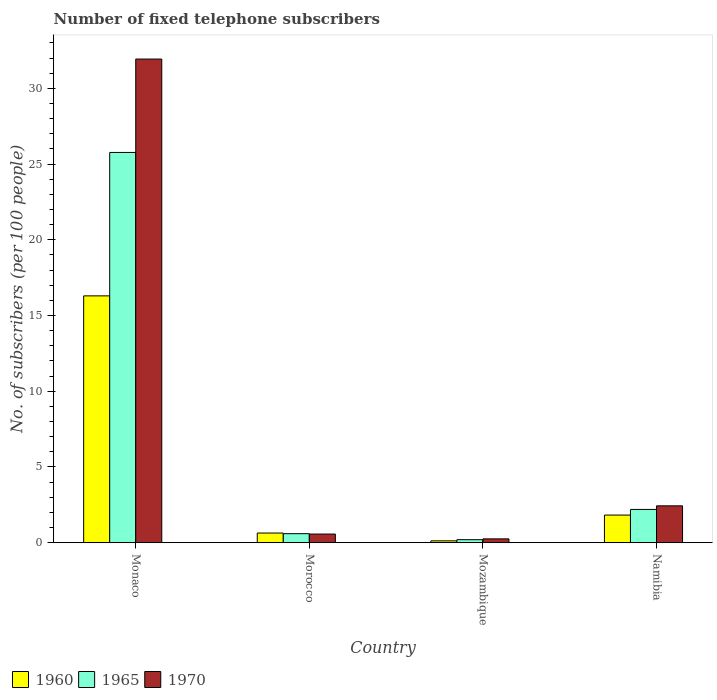Are the number of bars per tick equal to the number of legend labels?
Provide a short and direct response. Yes. Are the number of bars on each tick of the X-axis equal?
Make the answer very short. Yes. What is the label of the 4th group of bars from the left?
Provide a short and direct response. Namibia. What is the number of fixed telephone subscribers in 1965 in Mozambique?
Your answer should be compact. 0.2. Across all countries, what is the maximum number of fixed telephone subscribers in 1965?
Keep it short and to the point. 25.77. Across all countries, what is the minimum number of fixed telephone subscribers in 1970?
Your response must be concise. 0.25. In which country was the number of fixed telephone subscribers in 1970 maximum?
Your response must be concise. Monaco. In which country was the number of fixed telephone subscribers in 1960 minimum?
Your answer should be very brief. Mozambique. What is the total number of fixed telephone subscribers in 1970 in the graph?
Provide a short and direct response. 35.2. What is the difference between the number of fixed telephone subscribers in 1970 in Monaco and that in Namibia?
Keep it short and to the point. 29.5. What is the difference between the number of fixed telephone subscribers in 1965 in Morocco and the number of fixed telephone subscribers in 1960 in Namibia?
Make the answer very short. -1.23. What is the average number of fixed telephone subscribers in 1960 per country?
Your answer should be very brief. 4.72. What is the difference between the number of fixed telephone subscribers of/in 1970 and number of fixed telephone subscribers of/in 1960 in Mozambique?
Ensure brevity in your answer.  0.13. In how many countries, is the number of fixed telephone subscribers in 1960 greater than 15?
Offer a very short reply. 1. What is the ratio of the number of fixed telephone subscribers in 1960 in Mozambique to that in Namibia?
Your answer should be compact. 0.07. What is the difference between the highest and the second highest number of fixed telephone subscribers in 1960?
Give a very brief answer. 14.47. What is the difference between the highest and the lowest number of fixed telephone subscribers in 1960?
Your response must be concise. 16.18. In how many countries, is the number of fixed telephone subscribers in 1965 greater than the average number of fixed telephone subscribers in 1965 taken over all countries?
Your answer should be very brief. 1. Is the sum of the number of fixed telephone subscribers in 1960 in Mozambique and Namibia greater than the maximum number of fixed telephone subscribers in 1965 across all countries?
Offer a very short reply. No. What does the 1st bar from the left in Morocco represents?
Provide a succinct answer. 1960. What does the 3rd bar from the right in Mozambique represents?
Give a very brief answer. 1960. Is it the case that in every country, the sum of the number of fixed telephone subscribers in 1970 and number of fixed telephone subscribers in 1965 is greater than the number of fixed telephone subscribers in 1960?
Provide a short and direct response. Yes. How many bars are there?
Offer a very short reply. 12. Are all the bars in the graph horizontal?
Provide a succinct answer. No. Are the values on the major ticks of Y-axis written in scientific E-notation?
Make the answer very short. No. Where does the legend appear in the graph?
Your response must be concise. Bottom left. How many legend labels are there?
Offer a terse response. 3. How are the legend labels stacked?
Make the answer very short. Horizontal. What is the title of the graph?
Provide a short and direct response. Number of fixed telephone subscribers. What is the label or title of the Y-axis?
Ensure brevity in your answer.  No. of subscribers (per 100 people). What is the No. of subscribers (per 100 people) of 1960 in Monaco?
Your answer should be very brief. 16.3. What is the No. of subscribers (per 100 people) in 1965 in Monaco?
Your answer should be compact. 25.77. What is the No. of subscribers (per 100 people) in 1970 in Monaco?
Offer a very short reply. 31.94. What is the No. of subscribers (per 100 people) in 1960 in Morocco?
Provide a short and direct response. 0.64. What is the No. of subscribers (per 100 people) in 1965 in Morocco?
Keep it short and to the point. 0.6. What is the No. of subscribers (per 100 people) of 1970 in Morocco?
Your answer should be compact. 0.57. What is the No. of subscribers (per 100 people) of 1960 in Mozambique?
Offer a very short reply. 0.12. What is the No. of subscribers (per 100 people) of 1965 in Mozambique?
Make the answer very short. 0.2. What is the No. of subscribers (per 100 people) of 1970 in Mozambique?
Your answer should be very brief. 0.25. What is the No. of subscribers (per 100 people) in 1960 in Namibia?
Offer a very short reply. 1.83. What is the No. of subscribers (per 100 people) in 1965 in Namibia?
Your answer should be compact. 2.2. What is the No. of subscribers (per 100 people) of 1970 in Namibia?
Give a very brief answer. 2.43. Across all countries, what is the maximum No. of subscribers (per 100 people) in 1960?
Offer a terse response. 16.3. Across all countries, what is the maximum No. of subscribers (per 100 people) in 1965?
Give a very brief answer. 25.77. Across all countries, what is the maximum No. of subscribers (per 100 people) of 1970?
Provide a short and direct response. 31.94. Across all countries, what is the minimum No. of subscribers (per 100 people) of 1960?
Keep it short and to the point. 0.12. Across all countries, what is the minimum No. of subscribers (per 100 people) of 1965?
Offer a very short reply. 0.2. Across all countries, what is the minimum No. of subscribers (per 100 people) in 1970?
Provide a short and direct response. 0.25. What is the total No. of subscribers (per 100 people) of 1960 in the graph?
Offer a terse response. 18.89. What is the total No. of subscribers (per 100 people) in 1965 in the graph?
Make the answer very short. 28.76. What is the total No. of subscribers (per 100 people) in 1970 in the graph?
Offer a very short reply. 35.2. What is the difference between the No. of subscribers (per 100 people) of 1960 in Monaco and that in Morocco?
Your response must be concise. 15.66. What is the difference between the No. of subscribers (per 100 people) of 1965 in Monaco and that in Morocco?
Your response must be concise. 25.17. What is the difference between the No. of subscribers (per 100 people) in 1970 in Monaco and that in Morocco?
Ensure brevity in your answer.  31.36. What is the difference between the No. of subscribers (per 100 people) in 1960 in Monaco and that in Mozambique?
Offer a very short reply. 16.18. What is the difference between the No. of subscribers (per 100 people) of 1965 in Monaco and that in Mozambique?
Your answer should be compact. 25.57. What is the difference between the No. of subscribers (per 100 people) of 1970 in Monaco and that in Mozambique?
Provide a short and direct response. 31.68. What is the difference between the No. of subscribers (per 100 people) of 1960 in Monaco and that in Namibia?
Your response must be concise. 14.47. What is the difference between the No. of subscribers (per 100 people) in 1965 in Monaco and that in Namibia?
Your answer should be compact. 23.57. What is the difference between the No. of subscribers (per 100 people) of 1970 in Monaco and that in Namibia?
Offer a terse response. 29.5. What is the difference between the No. of subscribers (per 100 people) of 1960 in Morocco and that in Mozambique?
Your response must be concise. 0.52. What is the difference between the No. of subscribers (per 100 people) in 1965 in Morocco and that in Mozambique?
Provide a succinct answer. 0.4. What is the difference between the No. of subscribers (per 100 people) in 1970 in Morocco and that in Mozambique?
Ensure brevity in your answer.  0.32. What is the difference between the No. of subscribers (per 100 people) of 1960 in Morocco and that in Namibia?
Provide a short and direct response. -1.19. What is the difference between the No. of subscribers (per 100 people) in 1965 in Morocco and that in Namibia?
Your answer should be very brief. -1.6. What is the difference between the No. of subscribers (per 100 people) in 1970 in Morocco and that in Namibia?
Ensure brevity in your answer.  -1.86. What is the difference between the No. of subscribers (per 100 people) in 1960 in Mozambique and that in Namibia?
Offer a terse response. -1.7. What is the difference between the No. of subscribers (per 100 people) of 1965 in Mozambique and that in Namibia?
Your answer should be compact. -2. What is the difference between the No. of subscribers (per 100 people) in 1970 in Mozambique and that in Namibia?
Keep it short and to the point. -2.18. What is the difference between the No. of subscribers (per 100 people) in 1960 in Monaco and the No. of subscribers (per 100 people) in 1965 in Morocco?
Your answer should be very brief. 15.7. What is the difference between the No. of subscribers (per 100 people) in 1960 in Monaco and the No. of subscribers (per 100 people) in 1970 in Morocco?
Ensure brevity in your answer.  15.73. What is the difference between the No. of subscribers (per 100 people) of 1965 in Monaco and the No. of subscribers (per 100 people) of 1970 in Morocco?
Ensure brevity in your answer.  25.2. What is the difference between the No. of subscribers (per 100 people) of 1960 in Monaco and the No. of subscribers (per 100 people) of 1965 in Mozambique?
Give a very brief answer. 16.1. What is the difference between the No. of subscribers (per 100 people) in 1960 in Monaco and the No. of subscribers (per 100 people) in 1970 in Mozambique?
Provide a short and direct response. 16.05. What is the difference between the No. of subscribers (per 100 people) of 1965 in Monaco and the No. of subscribers (per 100 people) of 1970 in Mozambique?
Your answer should be compact. 25.52. What is the difference between the No. of subscribers (per 100 people) of 1960 in Monaco and the No. of subscribers (per 100 people) of 1965 in Namibia?
Ensure brevity in your answer.  14.1. What is the difference between the No. of subscribers (per 100 people) of 1960 in Monaco and the No. of subscribers (per 100 people) of 1970 in Namibia?
Provide a succinct answer. 13.87. What is the difference between the No. of subscribers (per 100 people) in 1965 in Monaco and the No. of subscribers (per 100 people) in 1970 in Namibia?
Offer a terse response. 23.34. What is the difference between the No. of subscribers (per 100 people) of 1960 in Morocco and the No. of subscribers (per 100 people) of 1965 in Mozambique?
Give a very brief answer. 0.44. What is the difference between the No. of subscribers (per 100 people) in 1960 in Morocco and the No. of subscribers (per 100 people) in 1970 in Mozambique?
Offer a terse response. 0.38. What is the difference between the No. of subscribers (per 100 people) in 1965 in Morocco and the No. of subscribers (per 100 people) in 1970 in Mozambique?
Make the answer very short. 0.34. What is the difference between the No. of subscribers (per 100 people) of 1960 in Morocco and the No. of subscribers (per 100 people) of 1965 in Namibia?
Provide a short and direct response. -1.56. What is the difference between the No. of subscribers (per 100 people) of 1960 in Morocco and the No. of subscribers (per 100 people) of 1970 in Namibia?
Offer a terse response. -1.8. What is the difference between the No. of subscribers (per 100 people) in 1965 in Morocco and the No. of subscribers (per 100 people) in 1970 in Namibia?
Offer a terse response. -1.84. What is the difference between the No. of subscribers (per 100 people) in 1960 in Mozambique and the No. of subscribers (per 100 people) in 1965 in Namibia?
Provide a succinct answer. -2.07. What is the difference between the No. of subscribers (per 100 people) of 1960 in Mozambique and the No. of subscribers (per 100 people) of 1970 in Namibia?
Keep it short and to the point. -2.31. What is the difference between the No. of subscribers (per 100 people) of 1965 in Mozambique and the No. of subscribers (per 100 people) of 1970 in Namibia?
Provide a succinct answer. -2.23. What is the average No. of subscribers (per 100 people) of 1960 per country?
Your answer should be compact. 4.72. What is the average No. of subscribers (per 100 people) in 1965 per country?
Provide a succinct answer. 7.19. What is the average No. of subscribers (per 100 people) in 1970 per country?
Ensure brevity in your answer.  8.8. What is the difference between the No. of subscribers (per 100 people) in 1960 and No. of subscribers (per 100 people) in 1965 in Monaco?
Offer a terse response. -9.47. What is the difference between the No. of subscribers (per 100 people) of 1960 and No. of subscribers (per 100 people) of 1970 in Monaco?
Provide a succinct answer. -15.64. What is the difference between the No. of subscribers (per 100 people) of 1965 and No. of subscribers (per 100 people) of 1970 in Monaco?
Offer a terse response. -6.17. What is the difference between the No. of subscribers (per 100 people) of 1960 and No. of subscribers (per 100 people) of 1965 in Morocco?
Your answer should be very brief. 0.04. What is the difference between the No. of subscribers (per 100 people) of 1960 and No. of subscribers (per 100 people) of 1970 in Morocco?
Offer a terse response. 0.07. What is the difference between the No. of subscribers (per 100 people) of 1965 and No. of subscribers (per 100 people) of 1970 in Morocco?
Give a very brief answer. 0.02. What is the difference between the No. of subscribers (per 100 people) in 1960 and No. of subscribers (per 100 people) in 1965 in Mozambique?
Your answer should be very brief. -0.08. What is the difference between the No. of subscribers (per 100 people) in 1960 and No. of subscribers (per 100 people) in 1970 in Mozambique?
Your answer should be compact. -0.13. What is the difference between the No. of subscribers (per 100 people) of 1965 and No. of subscribers (per 100 people) of 1970 in Mozambique?
Your response must be concise. -0.05. What is the difference between the No. of subscribers (per 100 people) of 1960 and No. of subscribers (per 100 people) of 1965 in Namibia?
Provide a succinct answer. -0.37. What is the difference between the No. of subscribers (per 100 people) in 1960 and No. of subscribers (per 100 people) in 1970 in Namibia?
Ensure brevity in your answer.  -0.61. What is the difference between the No. of subscribers (per 100 people) of 1965 and No. of subscribers (per 100 people) of 1970 in Namibia?
Keep it short and to the point. -0.24. What is the ratio of the No. of subscribers (per 100 people) in 1960 in Monaco to that in Morocco?
Keep it short and to the point. 25.54. What is the ratio of the No. of subscribers (per 100 people) of 1965 in Monaco to that in Morocco?
Your response must be concise. 43.23. What is the ratio of the No. of subscribers (per 100 people) of 1970 in Monaco to that in Morocco?
Ensure brevity in your answer.  55.86. What is the ratio of the No. of subscribers (per 100 people) of 1960 in Monaco to that in Mozambique?
Offer a terse response. 132.56. What is the ratio of the No. of subscribers (per 100 people) of 1965 in Monaco to that in Mozambique?
Provide a short and direct response. 128.45. What is the ratio of the No. of subscribers (per 100 people) of 1970 in Monaco to that in Mozambique?
Make the answer very short. 125.8. What is the ratio of the No. of subscribers (per 100 people) of 1960 in Monaco to that in Namibia?
Offer a terse response. 8.93. What is the ratio of the No. of subscribers (per 100 people) of 1965 in Monaco to that in Namibia?
Your answer should be very brief. 11.73. What is the ratio of the No. of subscribers (per 100 people) in 1970 in Monaco to that in Namibia?
Your answer should be compact. 13.12. What is the ratio of the No. of subscribers (per 100 people) of 1960 in Morocco to that in Mozambique?
Offer a terse response. 5.19. What is the ratio of the No. of subscribers (per 100 people) in 1965 in Morocco to that in Mozambique?
Your answer should be compact. 2.97. What is the ratio of the No. of subscribers (per 100 people) in 1970 in Morocco to that in Mozambique?
Your answer should be compact. 2.25. What is the ratio of the No. of subscribers (per 100 people) in 1960 in Morocco to that in Namibia?
Give a very brief answer. 0.35. What is the ratio of the No. of subscribers (per 100 people) in 1965 in Morocco to that in Namibia?
Offer a very short reply. 0.27. What is the ratio of the No. of subscribers (per 100 people) of 1970 in Morocco to that in Namibia?
Your answer should be compact. 0.23. What is the ratio of the No. of subscribers (per 100 people) in 1960 in Mozambique to that in Namibia?
Your response must be concise. 0.07. What is the ratio of the No. of subscribers (per 100 people) of 1965 in Mozambique to that in Namibia?
Your answer should be very brief. 0.09. What is the ratio of the No. of subscribers (per 100 people) of 1970 in Mozambique to that in Namibia?
Give a very brief answer. 0.1. What is the difference between the highest and the second highest No. of subscribers (per 100 people) in 1960?
Ensure brevity in your answer.  14.47. What is the difference between the highest and the second highest No. of subscribers (per 100 people) of 1965?
Keep it short and to the point. 23.57. What is the difference between the highest and the second highest No. of subscribers (per 100 people) of 1970?
Provide a short and direct response. 29.5. What is the difference between the highest and the lowest No. of subscribers (per 100 people) of 1960?
Give a very brief answer. 16.18. What is the difference between the highest and the lowest No. of subscribers (per 100 people) of 1965?
Keep it short and to the point. 25.57. What is the difference between the highest and the lowest No. of subscribers (per 100 people) in 1970?
Give a very brief answer. 31.68. 